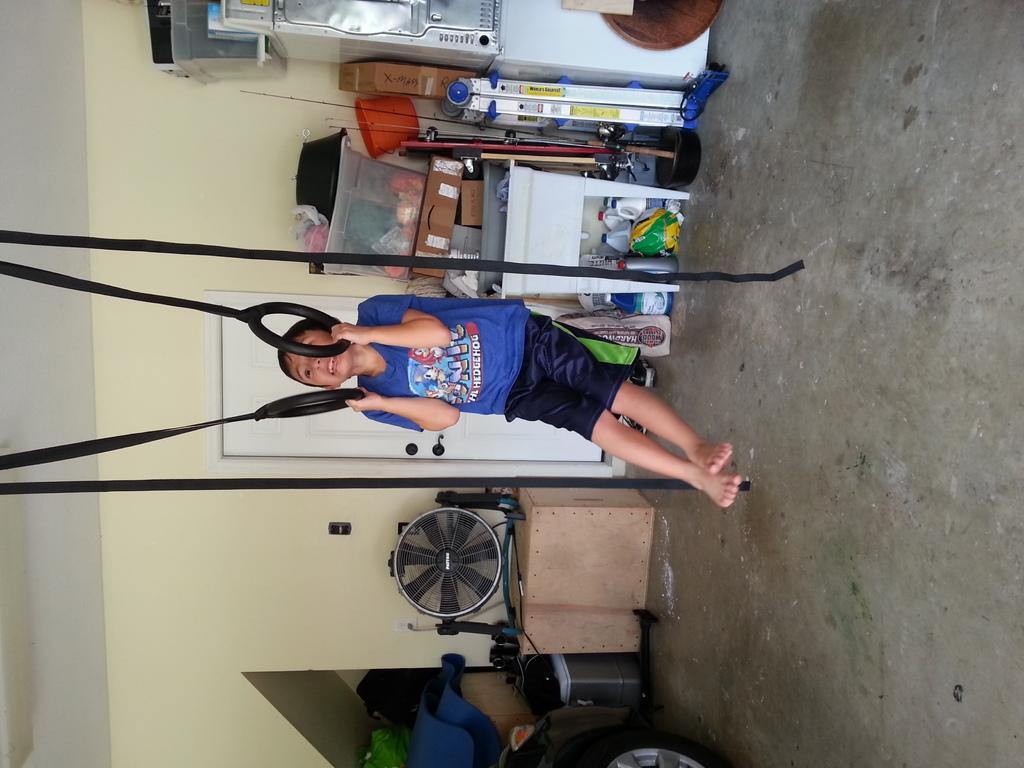Describe this image in one or two sentences. In this image we can see a boy holding rings with his hands. Here we can see a fan, box, bags, bottles, baskets, and few objects. In the background there is a wall. 